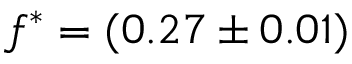Convert formula to latex. <formula><loc_0><loc_0><loc_500><loc_500>f ^ { \ast } = ( 0 . 2 7 \pm 0 . 0 1 )</formula> 